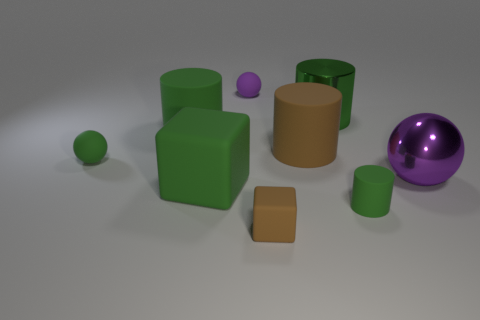Are there any patterns to the arrangement of objects in this image? The objects appear to be placed somewhat randomly, yet there is a visual balance created by the distribution of similar shapes and colors. The repetition of cylindrical and cuboid shapes, along with the green color, contributes to a patterned look. Was this arrangement likely intentional or accidental? Given the careful lighting and the composition, the arrangement seems intentional, likely designed to create a visually pleasing or thought-provoking scene, possibly for an artistic or educational purpose. 